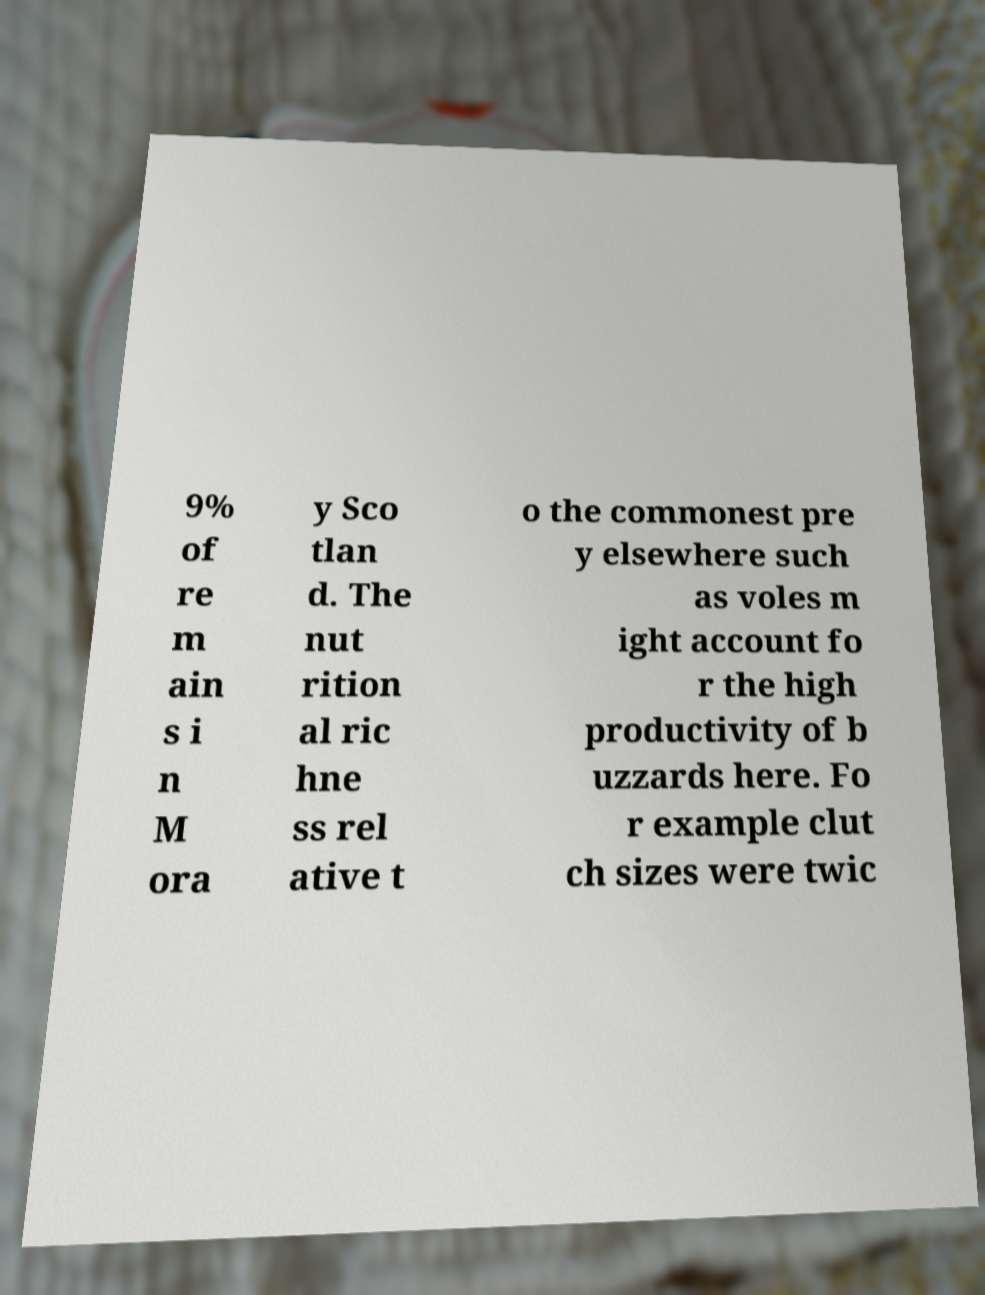Could you extract and type out the text from this image? 9% of re m ain s i n M ora y Sco tlan d. The nut rition al ric hne ss rel ative t o the commonest pre y elsewhere such as voles m ight account fo r the high productivity of b uzzards here. Fo r example clut ch sizes were twic 